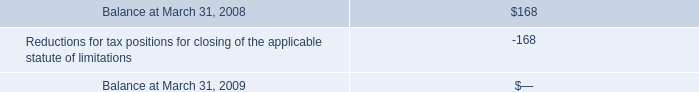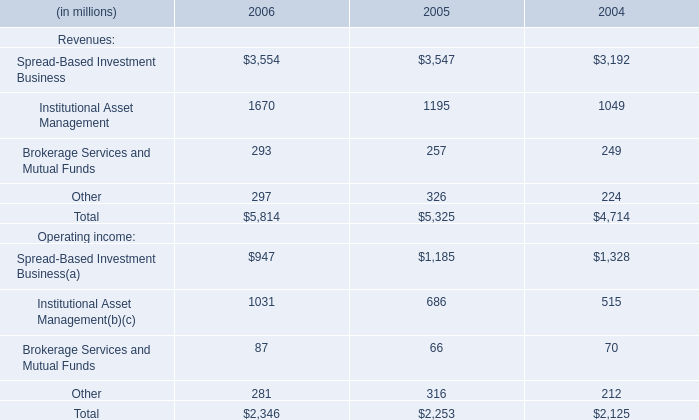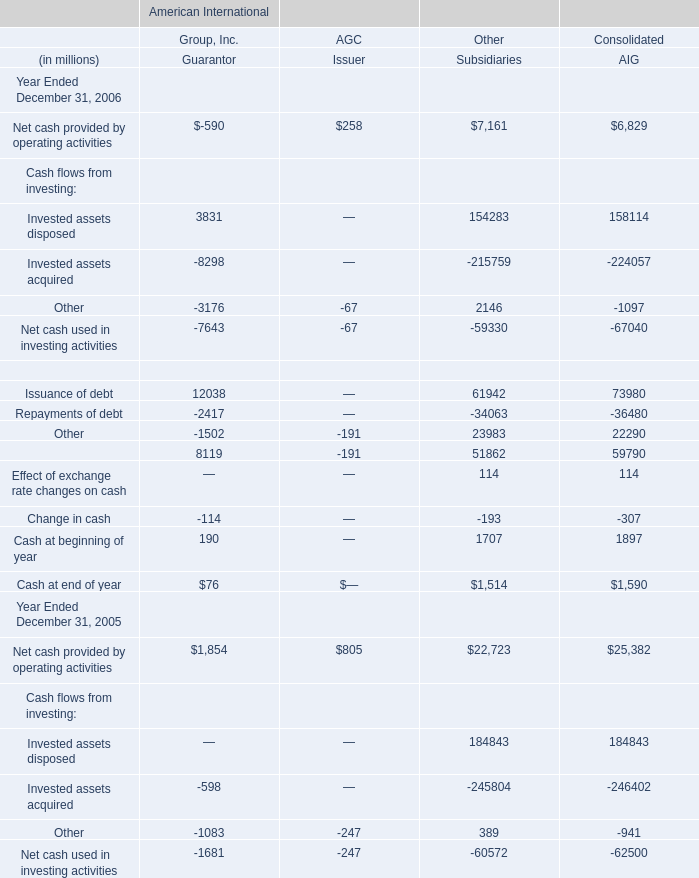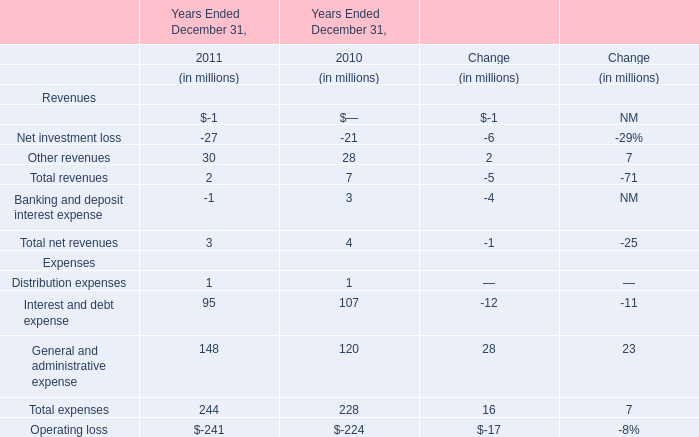what was the average payment per year for the state tax settlement , in millions? 
Computations: (168 / 3)
Answer: 56.0. 